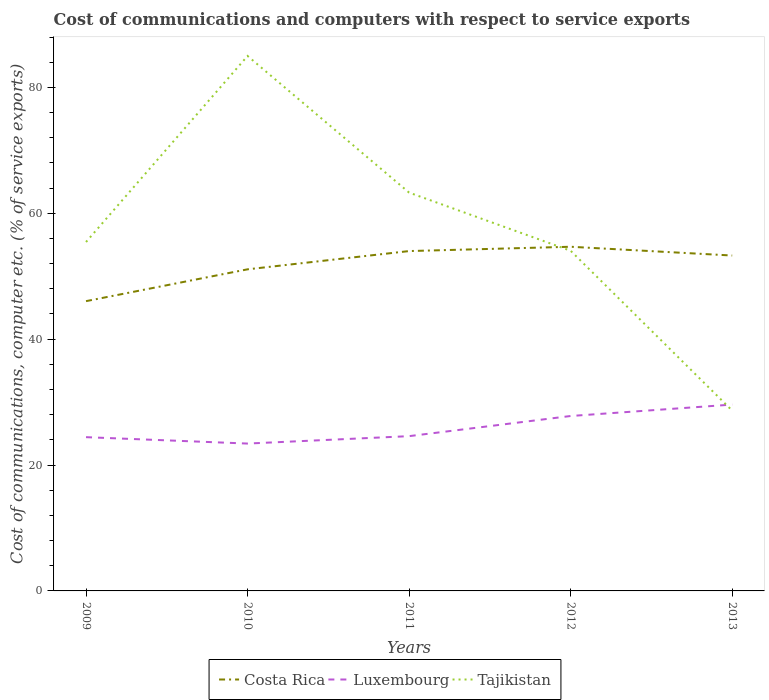Does the line corresponding to Costa Rica intersect with the line corresponding to Luxembourg?
Your response must be concise. No. Across all years, what is the maximum cost of communications and computers in Luxembourg?
Your response must be concise. 23.41. In which year was the cost of communications and computers in Costa Rica maximum?
Keep it short and to the point. 2009. What is the total cost of communications and computers in Tajikistan in the graph?
Provide a short and direct response. 34.64. What is the difference between the highest and the second highest cost of communications and computers in Tajikistan?
Your answer should be compact. 56.35. How many lines are there?
Offer a very short reply. 3. What is the difference between two consecutive major ticks on the Y-axis?
Provide a succinct answer. 20. Are the values on the major ticks of Y-axis written in scientific E-notation?
Give a very brief answer. No. Does the graph contain any zero values?
Offer a terse response. No. Where does the legend appear in the graph?
Your response must be concise. Bottom center. How are the legend labels stacked?
Your answer should be compact. Horizontal. What is the title of the graph?
Keep it short and to the point. Cost of communications and computers with respect to service exports. Does "Sweden" appear as one of the legend labels in the graph?
Keep it short and to the point. No. What is the label or title of the Y-axis?
Give a very brief answer. Cost of communications, computer etc. (% of service exports). What is the Cost of communications, computer etc. (% of service exports) in Costa Rica in 2009?
Your response must be concise. 46.04. What is the Cost of communications, computer etc. (% of service exports) in Luxembourg in 2009?
Offer a terse response. 24.43. What is the Cost of communications, computer etc. (% of service exports) of Tajikistan in 2009?
Ensure brevity in your answer.  55.43. What is the Cost of communications, computer etc. (% of service exports) of Costa Rica in 2010?
Offer a very short reply. 51.09. What is the Cost of communications, computer etc. (% of service exports) of Luxembourg in 2010?
Your response must be concise. 23.41. What is the Cost of communications, computer etc. (% of service exports) of Tajikistan in 2010?
Your answer should be compact. 84.99. What is the Cost of communications, computer etc. (% of service exports) of Costa Rica in 2011?
Make the answer very short. 53.99. What is the Cost of communications, computer etc. (% of service exports) of Luxembourg in 2011?
Offer a very short reply. 24.59. What is the Cost of communications, computer etc. (% of service exports) of Tajikistan in 2011?
Provide a short and direct response. 63.28. What is the Cost of communications, computer etc. (% of service exports) in Costa Rica in 2012?
Your response must be concise. 54.68. What is the Cost of communications, computer etc. (% of service exports) in Luxembourg in 2012?
Keep it short and to the point. 27.79. What is the Cost of communications, computer etc. (% of service exports) of Tajikistan in 2012?
Provide a short and direct response. 54.04. What is the Cost of communications, computer etc. (% of service exports) in Costa Rica in 2013?
Provide a succinct answer. 53.29. What is the Cost of communications, computer etc. (% of service exports) of Luxembourg in 2013?
Your response must be concise. 29.61. What is the Cost of communications, computer etc. (% of service exports) in Tajikistan in 2013?
Your answer should be compact. 28.65. Across all years, what is the maximum Cost of communications, computer etc. (% of service exports) of Costa Rica?
Provide a short and direct response. 54.68. Across all years, what is the maximum Cost of communications, computer etc. (% of service exports) of Luxembourg?
Provide a short and direct response. 29.61. Across all years, what is the maximum Cost of communications, computer etc. (% of service exports) of Tajikistan?
Give a very brief answer. 84.99. Across all years, what is the minimum Cost of communications, computer etc. (% of service exports) in Costa Rica?
Provide a succinct answer. 46.04. Across all years, what is the minimum Cost of communications, computer etc. (% of service exports) in Luxembourg?
Ensure brevity in your answer.  23.41. Across all years, what is the minimum Cost of communications, computer etc. (% of service exports) of Tajikistan?
Make the answer very short. 28.65. What is the total Cost of communications, computer etc. (% of service exports) in Costa Rica in the graph?
Keep it short and to the point. 259.09. What is the total Cost of communications, computer etc. (% of service exports) in Luxembourg in the graph?
Provide a succinct answer. 129.83. What is the total Cost of communications, computer etc. (% of service exports) of Tajikistan in the graph?
Keep it short and to the point. 286.4. What is the difference between the Cost of communications, computer etc. (% of service exports) of Costa Rica in 2009 and that in 2010?
Give a very brief answer. -5.06. What is the difference between the Cost of communications, computer etc. (% of service exports) of Luxembourg in 2009 and that in 2010?
Make the answer very short. 1.02. What is the difference between the Cost of communications, computer etc. (% of service exports) in Tajikistan in 2009 and that in 2010?
Provide a succinct answer. -29.56. What is the difference between the Cost of communications, computer etc. (% of service exports) in Costa Rica in 2009 and that in 2011?
Ensure brevity in your answer.  -7.96. What is the difference between the Cost of communications, computer etc. (% of service exports) of Luxembourg in 2009 and that in 2011?
Give a very brief answer. -0.16. What is the difference between the Cost of communications, computer etc. (% of service exports) of Tajikistan in 2009 and that in 2011?
Provide a succinct answer. -7.85. What is the difference between the Cost of communications, computer etc. (% of service exports) of Costa Rica in 2009 and that in 2012?
Ensure brevity in your answer.  -8.64. What is the difference between the Cost of communications, computer etc. (% of service exports) in Luxembourg in 2009 and that in 2012?
Provide a short and direct response. -3.36. What is the difference between the Cost of communications, computer etc. (% of service exports) of Tajikistan in 2009 and that in 2012?
Make the answer very short. 1.39. What is the difference between the Cost of communications, computer etc. (% of service exports) in Costa Rica in 2009 and that in 2013?
Make the answer very short. -7.25. What is the difference between the Cost of communications, computer etc. (% of service exports) of Luxembourg in 2009 and that in 2013?
Offer a terse response. -5.18. What is the difference between the Cost of communications, computer etc. (% of service exports) in Tajikistan in 2009 and that in 2013?
Your response must be concise. 26.79. What is the difference between the Cost of communications, computer etc. (% of service exports) in Costa Rica in 2010 and that in 2011?
Provide a short and direct response. -2.9. What is the difference between the Cost of communications, computer etc. (% of service exports) of Luxembourg in 2010 and that in 2011?
Your response must be concise. -1.18. What is the difference between the Cost of communications, computer etc. (% of service exports) of Tajikistan in 2010 and that in 2011?
Provide a short and direct response. 21.71. What is the difference between the Cost of communications, computer etc. (% of service exports) of Costa Rica in 2010 and that in 2012?
Give a very brief answer. -3.59. What is the difference between the Cost of communications, computer etc. (% of service exports) in Luxembourg in 2010 and that in 2012?
Offer a very short reply. -4.38. What is the difference between the Cost of communications, computer etc. (% of service exports) in Tajikistan in 2010 and that in 2012?
Keep it short and to the point. 30.95. What is the difference between the Cost of communications, computer etc. (% of service exports) in Costa Rica in 2010 and that in 2013?
Make the answer very short. -2.19. What is the difference between the Cost of communications, computer etc. (% of service exports) in Luxembourg in 2010 and that in 2013?
Keep it short and to the point. -6.19. What is the difference between the Cost of communications, computer etc. (% of service exports) of Tajikistan in 2010 and that in 2013?
Offer a very short reply. 56.34. What is the difference between the Cost of communications, computer etc. (% of service exports) of Costa Rica in 2011 and that in 2012?
Provide a succinct answer. -0.68. What is the difference between the Cost of communications, computer etc. (% of service exports) in Luxembourg in 2011 and that in 2012?
Ensure brevity in your answer.  -3.2. What is the difference between the Cost of communications, computer etc. (% of service exports) in Tajikistan in 2011 and that in 2012?
Your response must be concise. 9.24. What is the difference between the Cost of communications, computer etc. (% of service exports) of Costa Rica in 2011 and that in 2013?
Provide a succinct answer. 0.71. What is the difference between the Cost of communications, computer etc. (% of service exports) of Luxembourg in 2011 and that in 2013?
Your answer should be very brief. -5.02. What is the difference between the Cost of communications, computer etc. (% of service exports) of Tajikistan in 2011 and that in 2013?
Provide a succinct answer. 34.64. What is the difference between the Cost of communications, computer etc. (% of service exports) of Costa Rica in 2012 and that in 2013?
Give a very brief answer. 1.39. What is the difference between the Cost of communications, computer etc. (% of service exports) in Luxembourg in 2012 and that in 2013?
Provide a succinct answer. -1.82. What is the difference between the Cost of communications, computer etc. (% of service exports) of Tajikistan in 2012 and that in 2013?
Give a very brief answer. 25.39. What is the difference between the Cost of communications, computer etc. (% of service exports) in Costa Rica in 2009 and the Cost of communications, computer etc. (% of service exports) in Luxembourg in 2010?
Make the answer very short. 22.63. What is the difference between the Cost of communications, computer etc. (% of service exports) of Costa Rica in 2009 and the Cost of communications, computer etc. (% of service exports) of Tajikistan in 2010?
Keep it short and to the point. -38.96. What is the difference between the Cost of communications, computer etc. (% of service exports) in Luxembourg in 2009 and the Cost of communications, computer etc. (% of service exports) in Tajikistan in 2010?
Keep it short and to the point. -60.56. What is the difference between the Cost of communications, computer etc. (% of service exports) in Costa Rica in 2009 and the Cost of communications, computer etc. (% of service exports) in Luxembourg in 2011?
Give a very brief answer. 21.45. What is the difference between the Cost of communications, computer etc. (% of service exports) of Costa Rica in 2009 and the Cost of communications, computer etc. (% of service exports) of Tajikistan in 2011?
Your answer should be very brief. -17.25. What is the difference between the Cost of communications, computer etc. (% of service exports) in Luxembourg in 2009 and the Cost of communications, computer etc. (% of service exports) in Tajikistan in 2011?
Offer a very short reply. -38.86. What is the difference between the Cost of communications, computer etc. (% of service exports) of Costa Rica in 2009 and the Cost of communications, computer etc. (% of service exports) of Luxembourg in 2012?
Keep it short and to the point. 18.25. What is the difference between the Cost of communications, computer etc. (% of service exports) in Costa Rica in 2009 and the Cost of communications, computer etc. (% of service exports) in Tajikistan in 2012?
Provide a succinct answer. -8. What is the difference between the Cost of communications, computer etc. (% of service exports) of Luxembourg in 2009 and the Cost of communications, computer etc. (% of service exports) of Tajikistan in 2012?
Make the answer very short. -29.61. What is the difference between the Cost of communications, computer etc. (% of service exports) of Costa Rica in 2009 and the Cost of communications, computer etc. (% of service exports) of Luxembourg in 2013?
Give a very brief answer. 16.43. What is the difference between the Cost of communications, computer etc. (% of service exports) of Costa Rica in 2009 and the Cost of communications, computer etc. (% of service exports) of Tajikistan in 2013?
Your answer should be very brief. 17.39. What is the difference between the Cost of communications, computer etc. (% of service exports) in Luxembourg in 2009 and the Cost of communications, computer etc. (% of service exports) in Tajikistan in 2013?
Give a very brief answer. -4.22. What is the difference between the Cost of communications, computer etc. (% of service exports) in Costa Rica in 2010 and the Cost of communications, computer etc. (% of service exports) in Luxembourg in 2011?
Make the answer very short. 26.5. What is the difference between the Cost of communications, computer etc. (% of service exports) in Costa Rica in 2010 and the Cost of communications, computer etc. (% of service exports) in Tajikistan in 2011?
Give a very brief answer. -12.19. What is the difference between the Cost of communications, computer etc. (% of service exports) of Luxembourg in 2010 and the Cost of communications, computer etc. (% of service exports) of Tajikistan in 2011?
Offer a terse response. -39.87. What is the difference between the Cost of communications, computer etc. (% of service exports) of Costa Rica in 2010 and the Cost of communications, computer etc. (% of service exports) of Luxembourg in 2012?
Offer a terse response. 23.3. What is the difference between the Cost of communications, computer etc. (% of service exports) in Costa Rica in 2010 and the Cost of communications, computer etc. (% of service exports) in Tajikistan in 2012?
Your answer should be compact. -2.95. What is the difference between the Cost of communications, computer etc. (% of service exports) of Luxembourg in 2010 and the Cost of communications, computer etc. (% of service exports) of Tajikistan in 2012?
Ensure brevity in your answer.  -30.63. What is the difference between the Cost of communications, computer etc. (% of service exports) of Costa Rica in 2010 and the Cost of communications, computer etc. (% of service exports) of Luxembourg in 2013?
Provide a succinct answer. 21.49. What is the difference between the Cost of communications, computer etc. (% of service exports) of Costa Rica in 2010 and the Cost of communications, computer etc. (% of service exports) of Tajikistan in 2013?
Make the answer very short. 22.45. What is the difference between the Cost of communications, computer etc. (% of service exports) in Luxembourg in 2010 and the Cost of communications, computer etc. (% of service exports) in Tajikistan in 2013?
Provide a short and direct response. -5.24. What is the difference between the Cost of communications, computer etc. (% of service exports) of Costa Rica in 2011 and the Cost of communications, computer etc. (% of service exports) of Luxembourg in 2012?
Keep it short and to the point. 26.2. What is the difference between the Cost of communications, computer etc. (% of service exports) in Costa Rica in 2011 and the Cost of communications, computer etc. (% of service exports) in Tajikistan in 2012?
Your answer should be very brief. -0.05. What is the difference between the Cost of communications, computer etc. (% of service exports) of Luxembourg in 2011 and the Cost of communications, computer etc. (% of service exports) of Tajikistan in 2012?
Provide a short and direct response. -29.45. What is the difference between the Cost of communications, computer etc. (% of service exports) of Costa Rica in 2011 and the Cost of communications, computer etc. (% of service exports) of Luxembourg in 2013?
Make the answer very short. 24.39. What is the difference between the Cost of communications, computer etc. (% of service exports) of Costa Rica in 2011 and the Cost of communications, computer etc. (% of service exports) of Tajikistan in 2013?
Your response must be concise. 25.35. What is the difference between the Cost of communications, computer etc. (% of service exports) in Luxembourg in 2011 and the Cost of communications, computer etc. (% of service exports) in Tajikistan in 2013?
Your answer should be compact. -4.06. What is the difference between the Cost of communications, computer etc. (% of service exports) in Costa Rica in 2012 and the Cost of communications, computer etc. (% of service exports) in Luxembourg in 2013?
Your answer should be compact. 25.07. What is the difference between the Cost of communications, computer etc. (% of service exports) in Costa Rica in 2012 and the Cost of communications, computer etc. (% of service exports) in Tajikistan in 2013?
Your response must be concise. 26.03. What is the difference between the Cost of communications, computer etc. (% of service exports) in Luxembourg in 2012 and the Cost of communications, computer etc. (% of service exports) in Tajikistan in 2013?
Your answer should be very brief. -0.86. What is the average Cost of communications, computer etc. (% of service exports) in Costa Rica per year?
Keep it short and to the point. 51.82. What is the average Cost of communications, computer etc. (% of service exports) in Luxembourg per year?
Your response must be concise. 25.97. What is the average Cost of communications, computer etc. (% of service exports) in Tajikistan per year?
Offer a very short reply. 57.28. In the year 2009, what is the difference between the Cost of communications, computer etc. (% of service exports) in Costa Rica and Cost of communications, computer etc. (% of service exports) in Luxembourg?
Offer a terse response. 21.61. In the year 2009, what is the difference between the Cost of communications, computer etc. (% of service exports) in Costa Rica and Cost of communications, computer etc. (% of service exports) in Tajikistan?
Your response must be concise. -9.4. In the year 2009, what is the difference between the Cost of communications, computer etc. (% of service exports) in Luxembourg and Cost of communications, computer etc. (% of service exports) in Tajikistan?
Your answer should be very brief. -31.01. In the year 2010, what is the difference between the Cost of communications, computer etc. (% of service exports) of Costa Rica and Cost of communications, computer etc. (% of service exports) of Luxembourg?
Keep it short and to the point. 27.68. In the year 2010, what is the difference between the Cost of communications, computer etc. (% of service exports) in Costa Rica and Cost of communications, computer etc. (% of service exports) in Tajikistan?
Provide a short and direct response. -33.9. In the year 2010, what is the difference between the Cost of communications, computer etc. (% of service exports) of Luxembourg and Cost of communications, computer etc. (% of service exports) of Tajikistan?
Offer a very short reply. -61.58. In the year 2011, what is the difference between the Cost of communications, computer etc. (% of service exports) of Costa Rica and Cost of communications, computer etc. (% of service exports) of Luxembourg?
Offer a very short reply. 29.4. In the year 2011, what is the difference between the Cost of communications, computer etc. (% of service exports) in Costa Rica and Cost of communications, computer etc. (% of service exports) in Tajikistan?
Offer a terse response. -9.29. In the year 2011, what is the difference between the Cost of communications, computer etc. (% of service exports) in Luxembourg and Cost of communications, computer etc. (% of service exports) in Tajikistan?
Your response must be concise. -38.69. In the year 2012, what is the difference between the Cost of communications, computer etc. (% of service exports) in Costa Rica and Cost of communications, computer etc. (% of service exports) in Luxembourg?
Your response must be concise. 26.89. In the year 2012, what is the difference between the Cost of communications, computer etc. (% of service exports) of Costa Rica and Cost of communications, computer etc. (% of service exports) of Tajikistan?
Your answer should be compact. 0.64. In the year 2012, what is the difference between the Cost of communications, computer etc. (% of service exports) of Luxembourg and Cost of communications, computer etc. (% of service exports) of Tajikistan?
Your response must be concise. -26.25. In the year 2013, what is the difference between the Cost of communications, computer etc. (% of service exports) of Costa Rica and Cost of communications, computer etc. (% of service exports) of Luxembourg?
Your answer should be compact. 23.68. In the year 2013, what is the difference between the Cost of communications, computer etc. (% of service exports) of Costa Rica and Cost of communications, computer etc. (% of service exports) of Tajikistan?
Offer a very short reply. 24.64. In the year 2013, what is the difference between the Cost of communications, computer etc. (% of service exports) of Luxembourg and Cost of communications, computer etc. (% of service exports) of Tajikistan?
Provide a short and direct response. 0.96. What is the ratio of the Cost of communications, computer etc. (% of service exports) in Costa Rica in 2009 to that in 2010?
Offer a terse response. 0.9. What is the ratio of the Cost of communications, computer etc. (% of service exports) in Luxembourg in 2009 to that in 2010?
Provide a succinct answer. 1.04. What is the ratio of the Cost of communications, computer etc. (% of service exports) in Tajikistan in 2009 to that in 2010?
Provide a short and direct response. 0.65. What is the ratio of the Cost of communications, computer etc. (% of service exports) of Costa Rica in 2009 to that in 2011?
Your response must be concise. 0.85. What is the ratio of the Cost of communications, computer etc. (% of service exports) in Luxembourg in 2009 to that in 2011?
Provide a succinct answer. 0.99. What is the ratio of the Cost of communications, computer etc. (% of service exports) in Tajikistan in 2009 to that in 2011?
Ensure brevity in your answer.  0.88. What is the ratio of the Cost of communications, computer etc. (% of service exports) of Costa Rica in 2009 to that in 2012?
Keep it short and to the point. 0.84. What is the ratio of the Cost of communications, computer etc. (% of service exports) of Luxembourg in 2009 to that in 2012?
Make the answer very short. 0.88. What is the ratio of the Cost of communications, computer etc. (% of service exports) of Tajikistan in 2009 to that in 2012?
Offer a terse response. 1.03. What is the ratio of the Cost of communications, computer etc. (% of service exports) of Costa Rica in 2009 to that in 2013?
Your answer should be very brief. 0.86. What is the ratio of the Cost of communications, computer etc. (% of service exports) in Luxembourg in 2009 to that in 2013?
Offer a terse response. 0.83. What is the ratio of the Cost of communications, computer etc. (% of service exports) of Tajikistan in 2009 to that in 2013?
Your response must be concise. 1.94. What is the ratio of the Cost of communications, computer etc. (% of service exports) of Costa Rica in 2010 to that in 2011?
Your answer should be compact. 0.95. What is the ratio of the Cost of communications, computer etc. (% of service exports) in Luxembourg in 2010 to that in 2011?
Offer a very short reply. 0.95. What is the ratio of the Cost of communications, computer etc. (% of service exports) in Tajikistan in 2010 to that in 2011?
Give a very brief answer. 1.34. What is the ratio of the Cost of communications, computer etc. (% of service exports) of Costa Rica in 2010 to that in 2012?
Your answer should be compact. 0.93. What is the ratio of the Cost of communications, computer etc. (% of service exports) in Luxembourg in 2010 to that in 2012?
Offer a terse response. 0.84. What is the ratio of the Cost of communications, computer etc. (% of service exports) in Tajikistan in 2010 to that in 2012?
Provide a short and direct response. 1.57. What is the ratio of the Cost of communications, computer etc. (% of service exports) in Costa Rica in 2010 to that in 2013?
Your answer should be compact. 0.96. What is the ratio of the Cost of communications, computer etc. (% of service exports) in Luxembourg in 2010 to that in 2013?
Give a very brief answer. 0.79. What is the ratio of the Cost of communications, computer etc. (% of service exports) in Tajikistan in 2010 to that in 2013?
Provide a succinct answer. 2.97. What is the ratio of the Cost of communications, computer etc. (% of service exports) of Costa Rica in 2011 to that in 2012?
Ensure brevity in your answer.  0.99. What is the ratio of the Cost of communications, computer etc. (% of service exports) in Luxembourg in 2011 to that in 2012?
Ensure brevity in your answer.  0.88. What is the ratio of the Cost of communications, computer etc. (% of service exports) of Tajikistan in 2011 to that in 2012?
Ensure brevity in your answer.  1.17. What is the ratio of the Cost of communications, computer etc. (% of service exports) in Costa Rica in 2011 to that in 2013?
Offer a terse response. 1.01. What is the ratio of the Cost of communications, computer etc. (% of service exports) in Luxembourg in 2011 to that in 2013?
Your answer should be very brief. 0.83. What is the ratio of the Cost of communications, computer etc. (% of service exports) of Tajikistan in 2011 to that in 2013?
Give a very brief answer. 2.21. What is the ratio of the Cost of communications, computer etc. (% of service exports) of Costa Rica in 2012 to that in 2013?
Give a very brief answer. 1.03. What is the ratio of the Cost of communications, computer etc. (% of service exports) of Luxembourg in 2012 to that in 2013?
Provide a short and direct response. 0.94. What is the ratio of the Cost of communications, computer etc. (% of service exports) in Tajikistan in 2012 to that in 2013?
Make the answer very short. 1.89. What is the difference between the highest and the second highest Cost of communications, computer etc. (% of service exports) of Costa Rica?
Give a very brief answer. 0.68. What is the difference between the highest and the second highest Cost of communications, computer etc. (% of service exports) in Luxembourg?
Provide a succinct answer. 1.82. What is the difference between the highest and the second highest Cost of communications, computer etc. (% of service exports) of Tajikistan?
Provide a succinct answer. 21.71. What is the difference between the highest and the lowest Cost of communications, computer etc. (% of service exports) in Costa Rica?
Offer a very short reply. 8.64. What is the difference between the highest and the lowest Cost of communications, computer etc. (% of service exports) of Luxembourg?
Make the answer very short. 6.19. What is the difference between the highest and the lowest Cost of communications, computer etc. (% of service exports) of Tajikistan?
Make the answer very short. 56.34. 